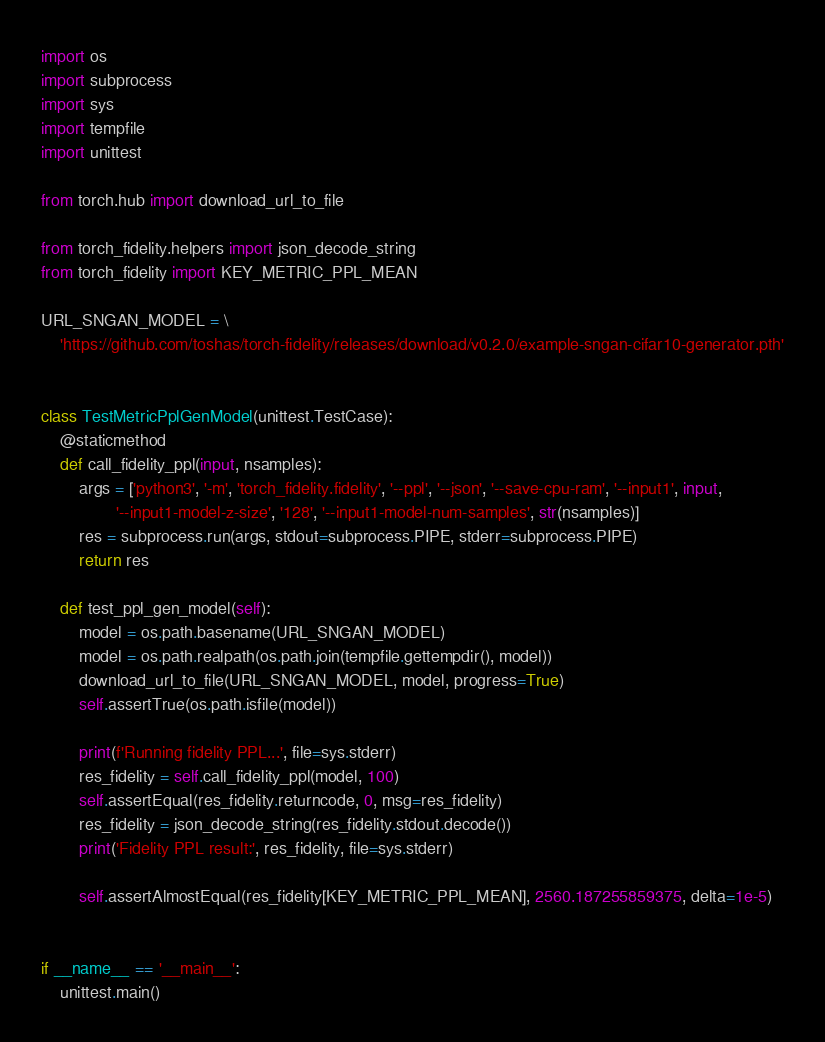Convert code to text. <code><loc_0><loc_0><loc_500><loc_500><_Python_>import os
import subprocess
import sys
import tempfile
import unittest

from torch.hub import download_url_to_file

from torch_fidelity.helpers import json_decode_string
from torch_fidelity import KEY_METRIC_PPL_MEAN

URL_SNGAN_MODEL = \
    'https://github.com/toshas/torch-fidelity/releases/download/v0.2.0/example-sngan-cifar10-generator.pth'


class TestMetricPplGenModel(unittest.TestCase):
    @staticmethod
    def call_fidelity_ppl(input, nsamples):
        args = ['python3', '-m', 'torch_fidelity.fidelity', '--ppl', '--json', '--save-cpu-ram', '--input1', input,
                '--input1-model-z-size', '128', '--input1-model-num-samples', str(nsamples)]
        res = subprocess.run(args, stdout=subprocess.PIPE, stderr=subprocess.PIPE)
        return res

    def test_ppl_gen_model(self):
        model = os.path.basename(URL_SNGAN_MODEL)
        model = os.path.realpath(os.path.join(tempfile.gettempdir(), model))
        download_url_to_file(URL_SNGAN_MODEL, model, progress=True)
        self.assertTrue(os.path.isfile(model))

        print(f'Running fidelity PPL...', file=sys.stderr)
        res_fidelity = self.call_fidelity_ppl(model, 100)
        self.assertEqual(res_fidelity.returncode, 0, msg=res_fidelity)
        res_fidelity = json_decode_string(res_fidelity.stdout.decode())
        print('Fidelity PPL result:', res_fidelity, file=sys.stderr)

        self.assertAlmostEqual(res_fidelity[KEY_METRIC_PPL_MEAN], 2560.187255859375, delta=1e-5)


if __name__ == '__main__':
    unittest.main()
</code> 